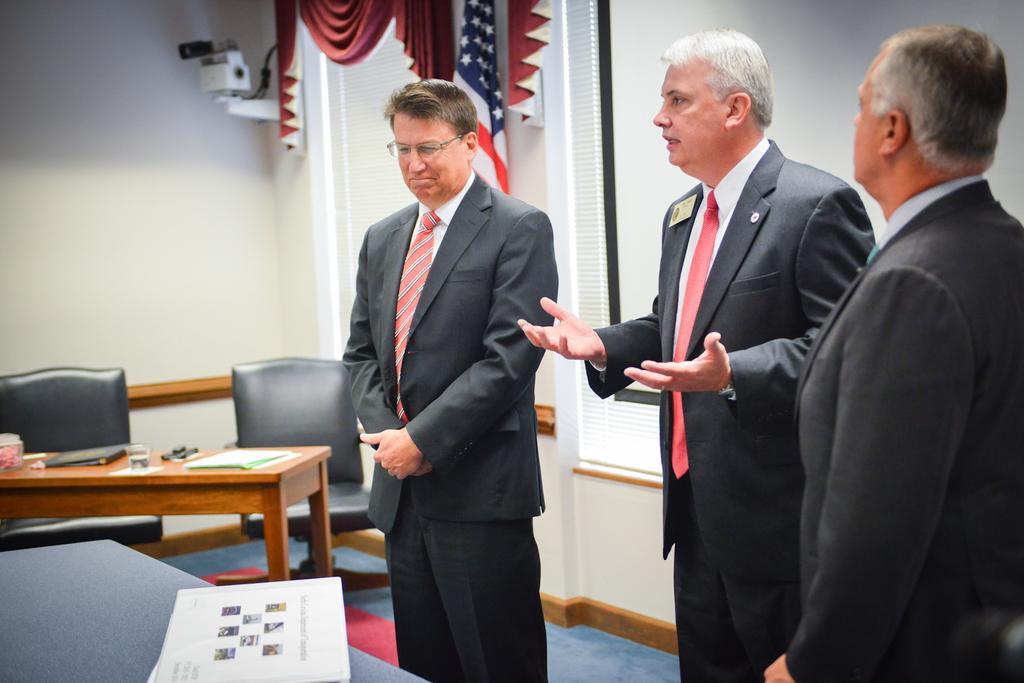Could you give a brief overview of what you see in this image? In this picture we have three people who are wearing black suit and red tie and have a batch and in front of them there is a table which there is a paper and beside them there is a table on which we have a glass, file and some papers behind them there is a white board and a red color on the window and a flag. 